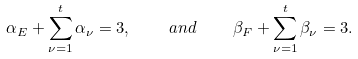Convert formula to latex. <formula><loc_0><loc_0><loc_500><loc_500>\alpha _ { E } + \sum _ { \nu = 1 } ^ { t } \alpha _ { \nu } = 3 , \quad a n d \quad \beta _ { F } + \sum _ { \nu = 1 } ^ { t } \beta _ { \nu } = 3 .</formula> 